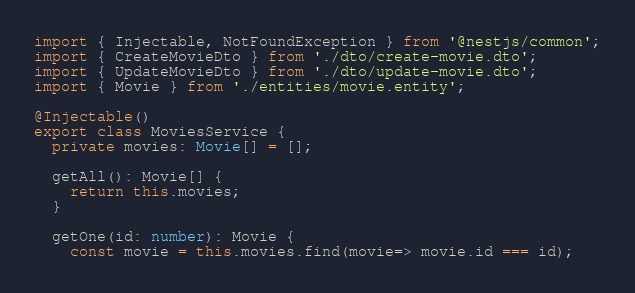<code> <loc_0><loc_0><loc_500><loc_500><_TypeScript_>import { Injectable, NotFoundException } from '@nestjs/common';
import { CreateMovieDto } from './dto/create-movie.dto';
import { UpdateMovieDto } from './dto/update-movie.dto';
import { Movie } from './entities/movie.entity';

@Injectable()
export class MoviesService {
  private movies: Movie[] = [];

  getAll(): Movie[] {
    return this.movies;
  }

  getOne(id: number): Movie {
    const movie = this.movies.find(movie=> movie.id === id);</code> 